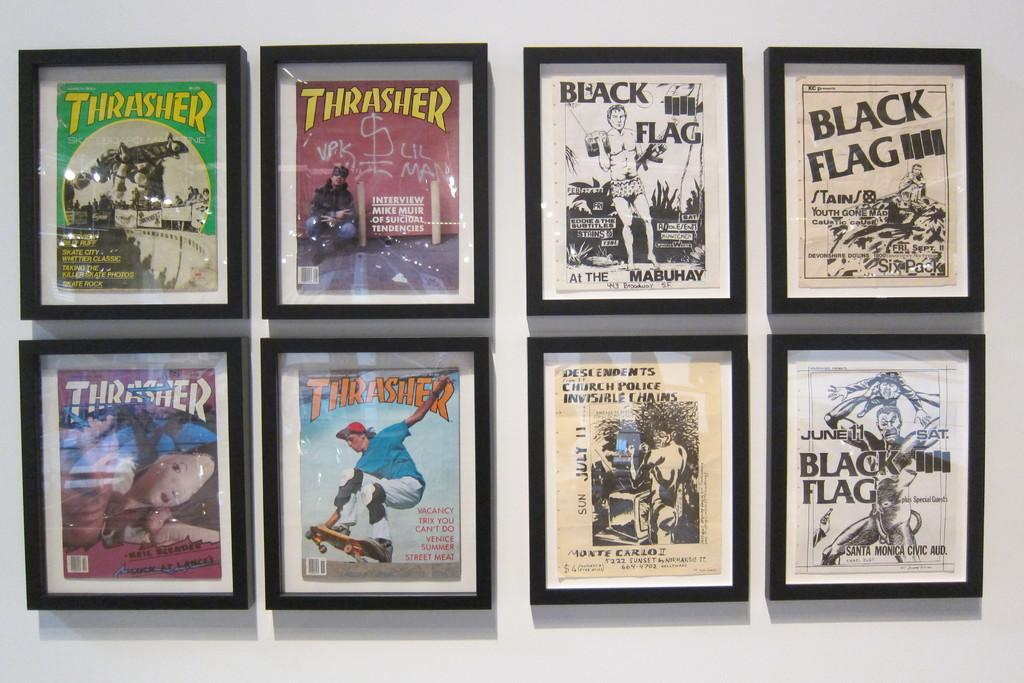<image>
Write a terse but informative summary of the picture. Eight frames displayed that include Thrasher and Black Flag prints 